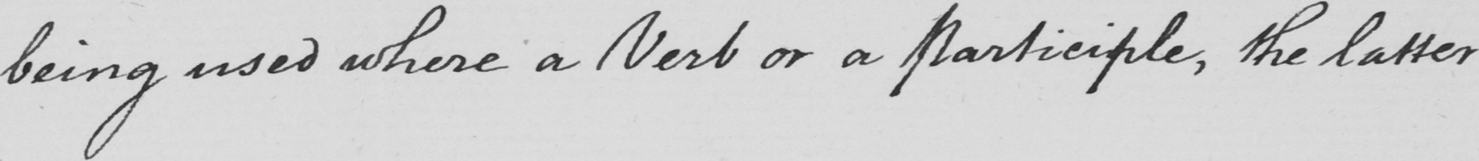Please provide the text content of this handwritten line. being used where a Verb or a Participle , the latter 